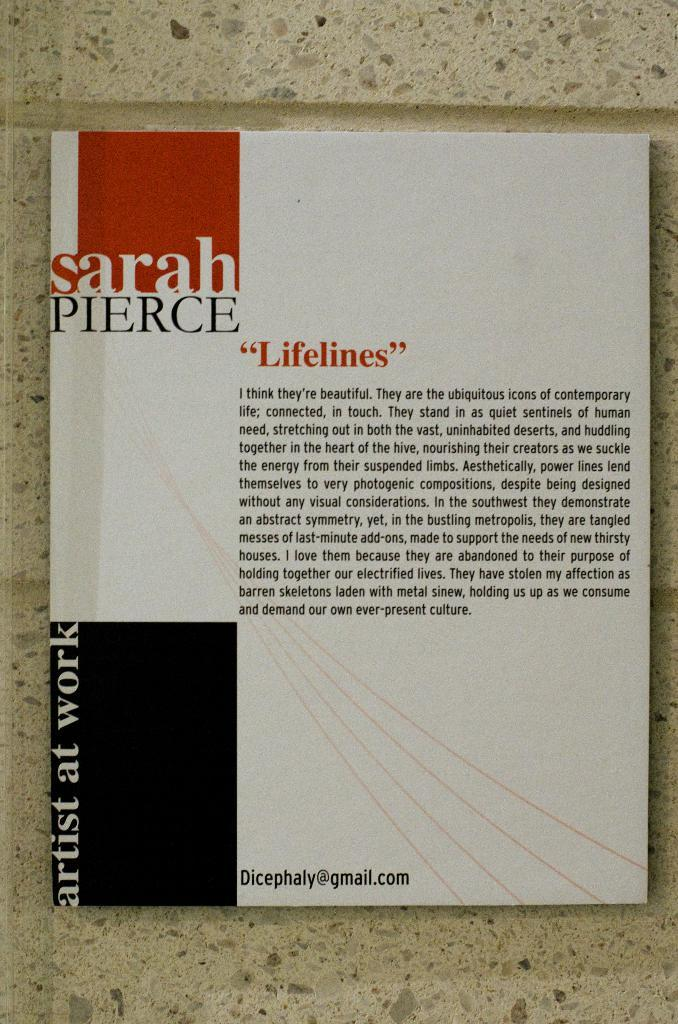Provide a one-sentence caption for the provided image. A paragraph titled Lifelines by Sarah Pierce in Artist At Work. 